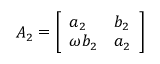Convert formula to latex. <formula><loc_0><loc_0><loc_500><loc_500>A _ { 2 } = { \left [ \begin{array} { l l } { a _ { 2 } } & { b _ { 2 } } \\ { \omega b _ { 2 } } & { a _ { 2 } } \end{array} \right ] }</formula> 